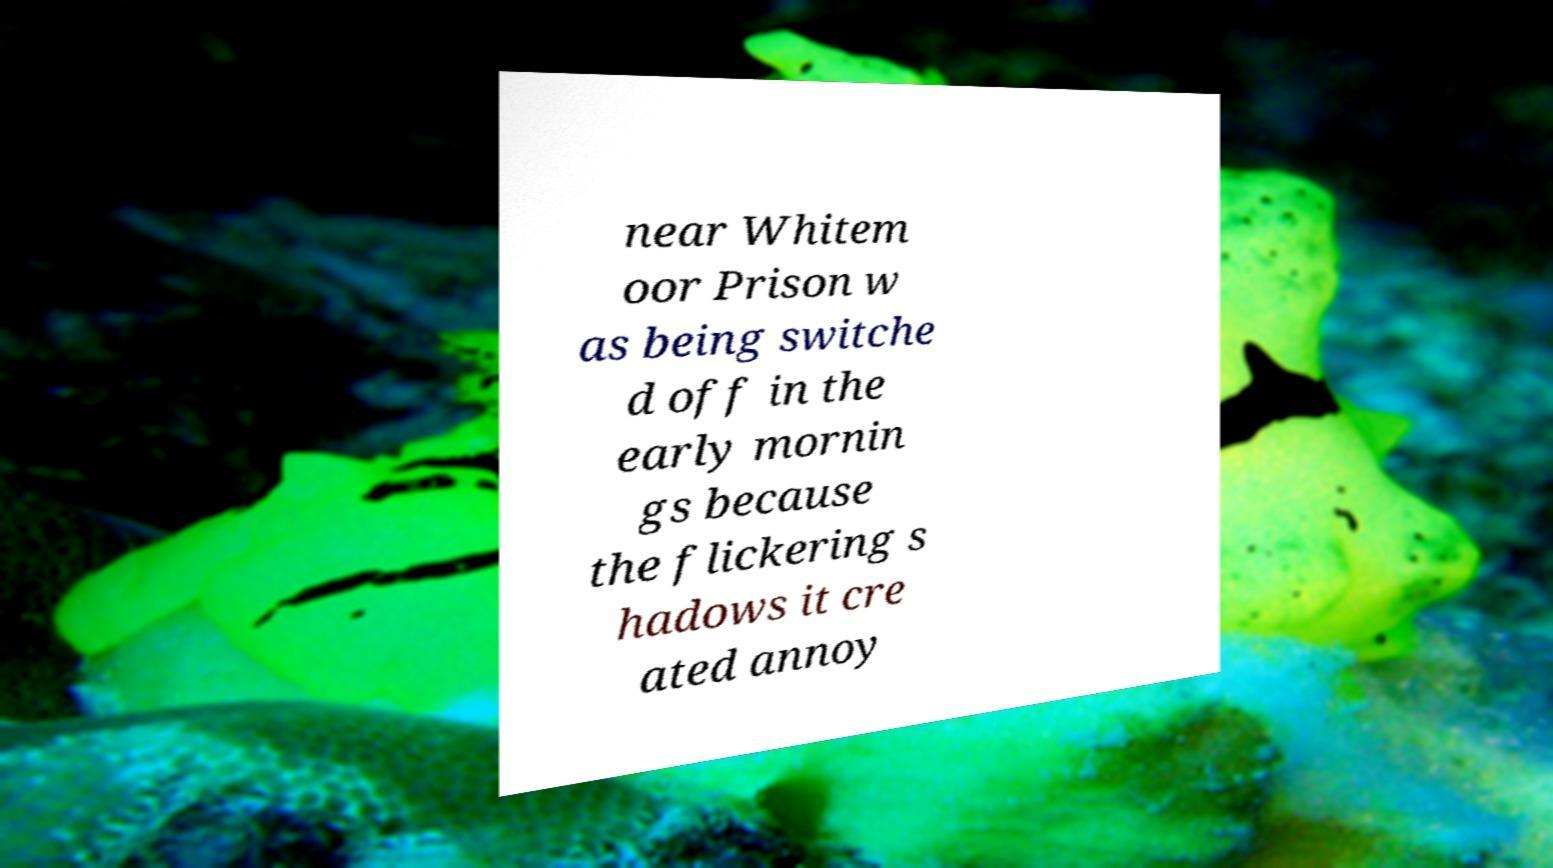Could you extract and type out the text from this image? near Whitem oor Prison w as being switche d off in the early mornin gs because the flickering s hadows it cre ated annoy 